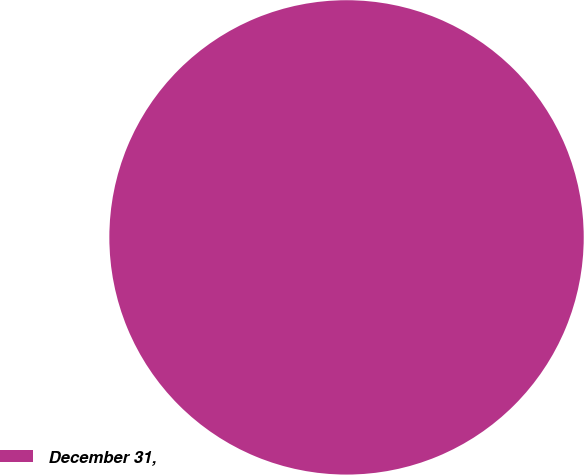Convert chart to OTSL. <chart><loc_0><loc_0><loc_500><loc_500><pie_chart><fcel>December 31,<nl><fcel>100.0%<nl></chart> 